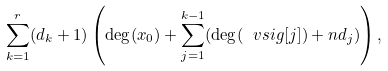<formula> <loc_0><loc_0><loc_500><loc_500>\sum _ { k = 1 } ^ { r } ( d _ { k } + 1 ) \left ( \deg ( x _ { 0 } ) + \sum _ { j = 1 } ^ { k - 1 } ( \deg ( \ v s i g [ j ] ) + n d _ { j } ) \right ) ,</formula> 